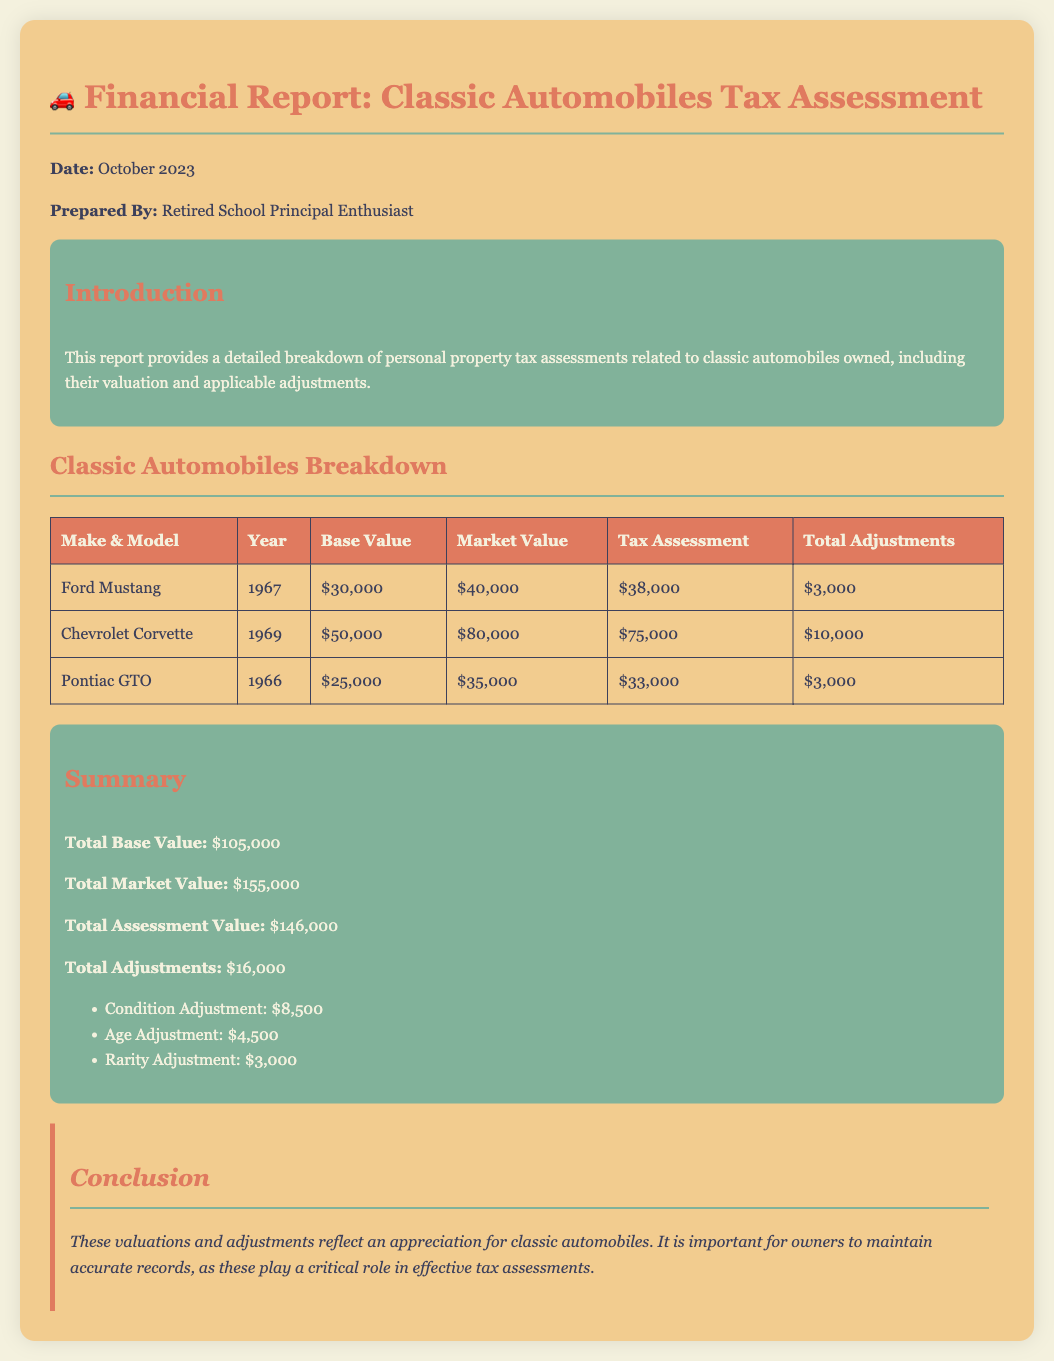What is the date of the report? The date of the report is specified in the document, which is written clearly at the top.
Answer: October 2023 What is the make and model of the car with the highest tax assessment? To determine the car with the highest tax assessment, we need to compare the tax assessments listed in the table.
Answer: Chevrolet Corvette What is the total base value of all classic automobiles? The total base value is a sum of the base values of each classic automobile listed in the summary section.
Answer: $105,000 What adjustments were applied to the classic automobiles? Adjustments are detailed in the summary section, listing specific types and their amounts.
Answer: Condition Adjustment, Age Adjustment, Rarity Adjustment How much is the market value of the Pontiac GTO? The market value for each automobile is displayed in the table under the column for market value.
Answer: $35,000 What is the total of all adjustments? The total adjustments are calculated and presented as part of the summary information.
Answer: $16,000 What was the base value of the Ford Mustang? The base value of each classic automobile is specified in the table beside its respective entry.
Answer: $30,000 What is the conclusion of the report? The conclusion section encapsulates the key message of the report regarding the importance of maintaining accurate records for classic automobile ownership.
Answer: Appreciation for classic automobiles How many classic automobiles are listed in the document? The document provides a table that contains entries for each classic automobile, which allows us to count them.
Answer: 3 